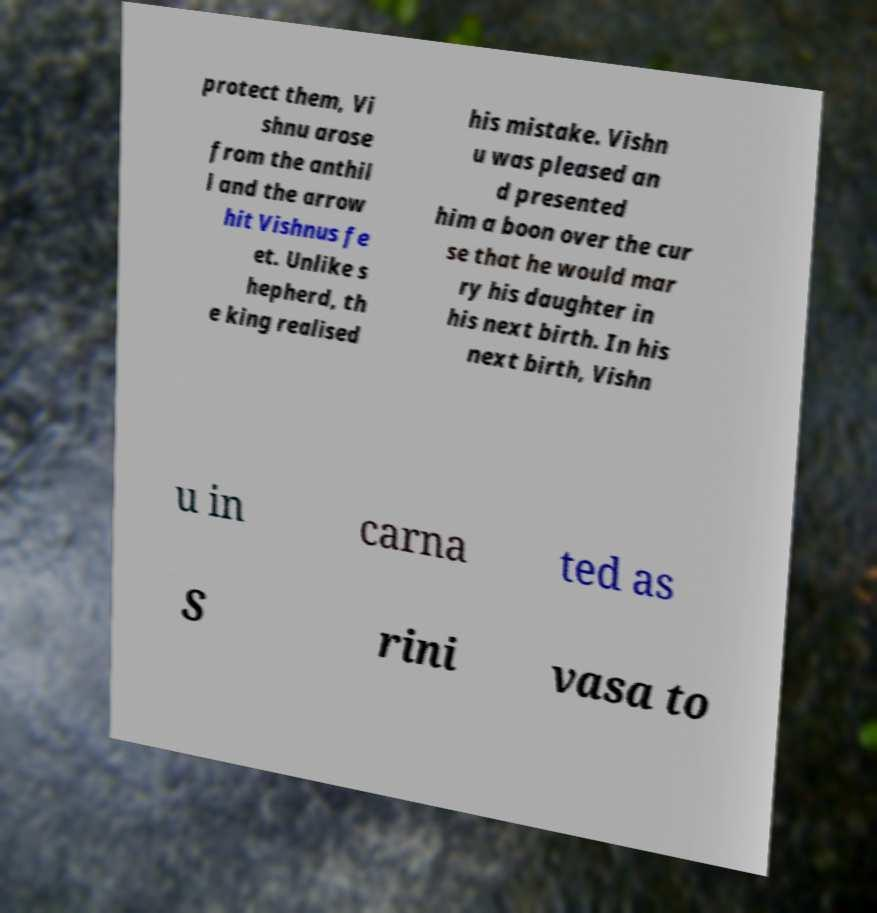Please read and relay the text visible in this image. What does it say? protect them, Vi shnu arose from the anthil l and the arrow hit Vishnus fe et. Unlike s hepherd, th e king realised his mistake. Vishn u was pleased an d presented him a boon over the cur se that he would mar ry his daughter in his next birth. In his next birth, Vishn u in carna ted as S rini vasa to 